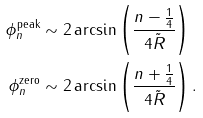Convert formula to latex. <formula><loc_0><loc_0><loc_500><loc_500>\phi ^ { \text {peak} } _ { n } & \sim 2 \arcsin \left ( \frac { n - \frac { 1 } { 4 } } { 4 \tilde { R } } \right ) \\ \phi ^ { \text {zero} } _ { n } & \sim 2 \arcsin \left ( \frac { n + \frac { 1 } { 4 } } { 4 \tilde { R } } \right ) .</formula> 